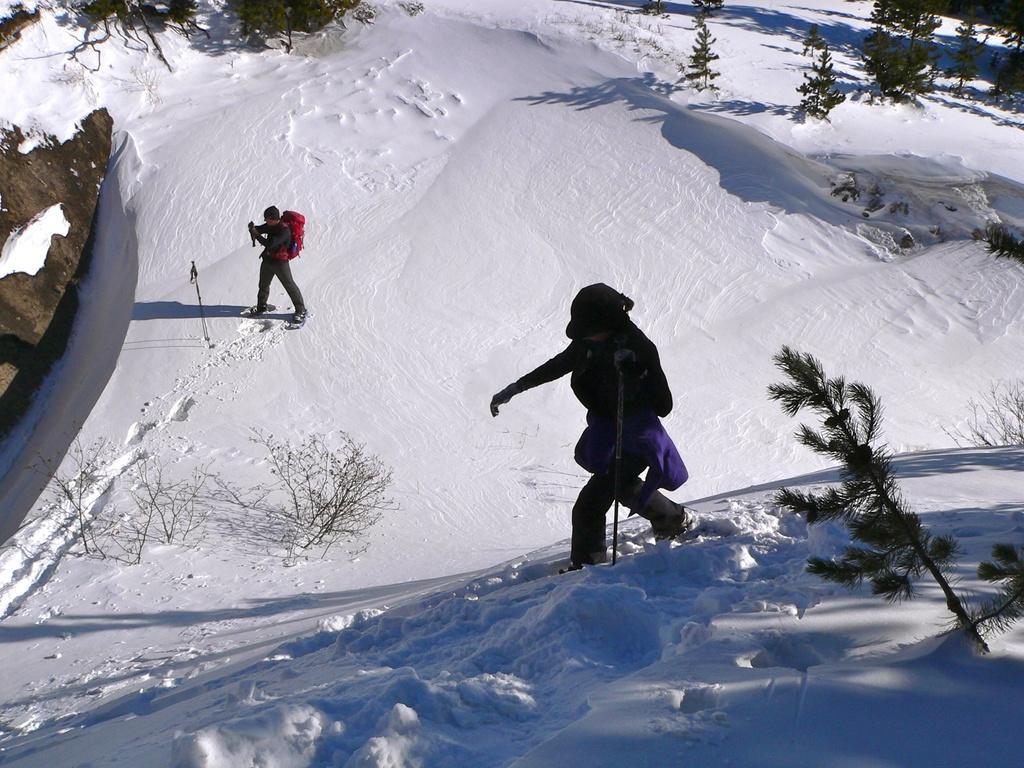Describe this image in one or two sentences. A person is standing another person is walking in the snow, these are trees. 